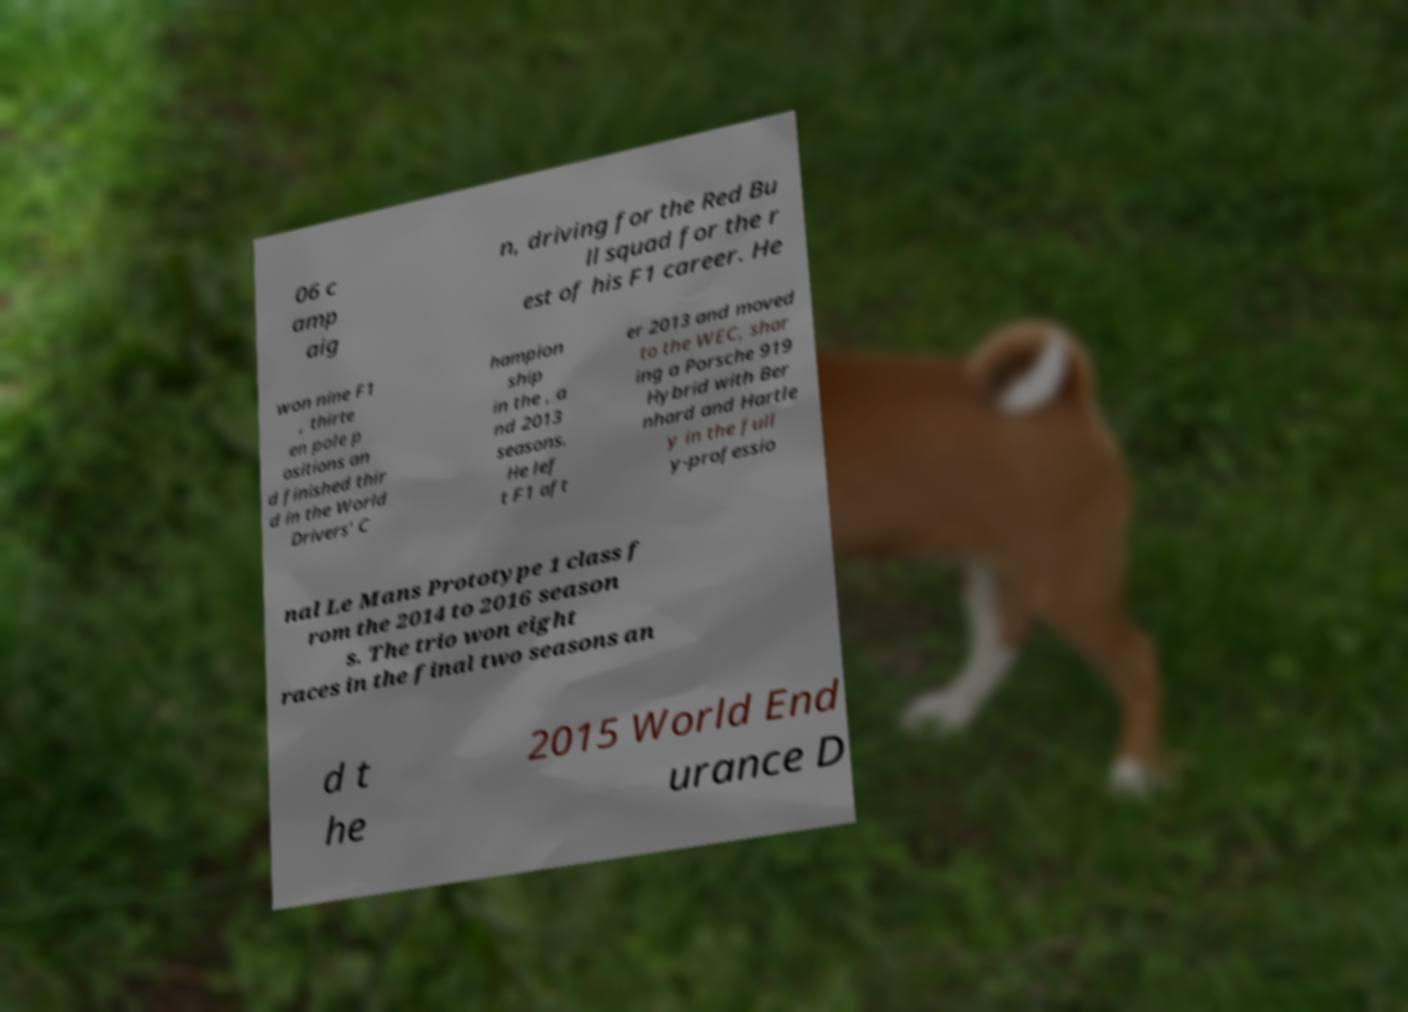Could you assist in decoding the text presented in this image and type it out clearly? 06 c amp aig n, driving for the Red Bu ll squad for the r est of his F1 career. He won nine F1 , thirte en pole p ositions an d finished thir d in the World Drivers' C hampion ship in the , a nd 2013 seasons. He lef t F1 aft er 2013 and moved to the WEC, shar ing a Porsche 919 Hybrid with Ber nhard and Hartle y in the full y-professio nal Le Mans Prototype 1 class f rom the 2014 to 2016 season s. The trio won eight races in the final two seasons an d t he 2015 World End urance D 